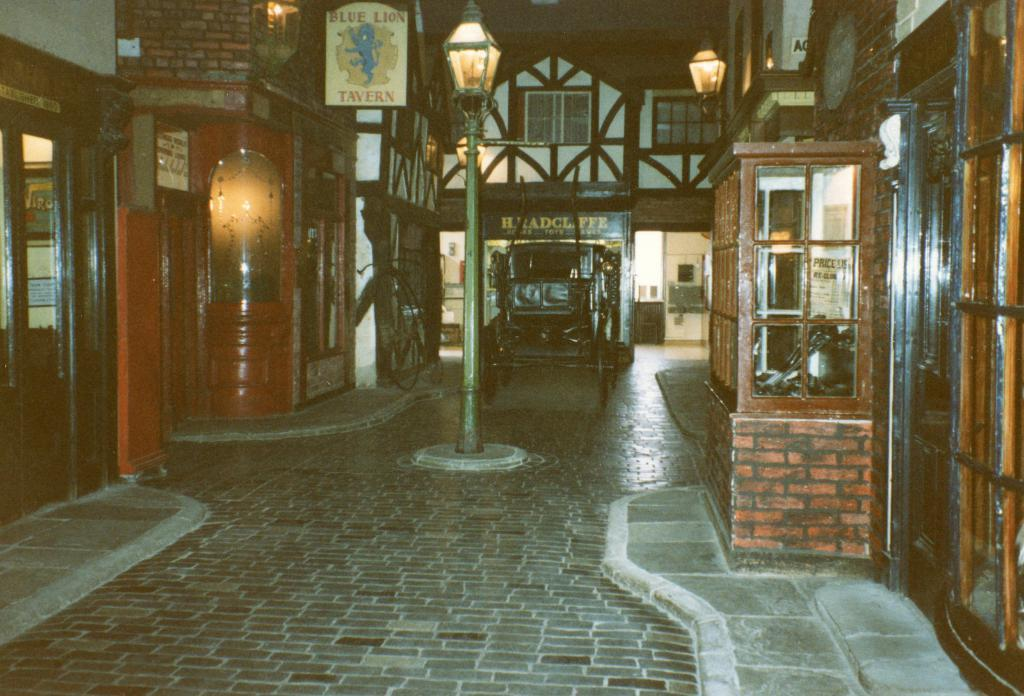What is attached to the pole in the image? There is a light attached to the pole in the image. What can be seen behind the pole? There appears to be a vehicle behind the pole. What is the lighting situation in the image? There are buildings with lights on both sides of the pole. What is present on one of the buildings? There is a board on one of the buildings. What type of reward is being offered on the board in the image? There is no mention of a reward or any information about the board's content in the image. 